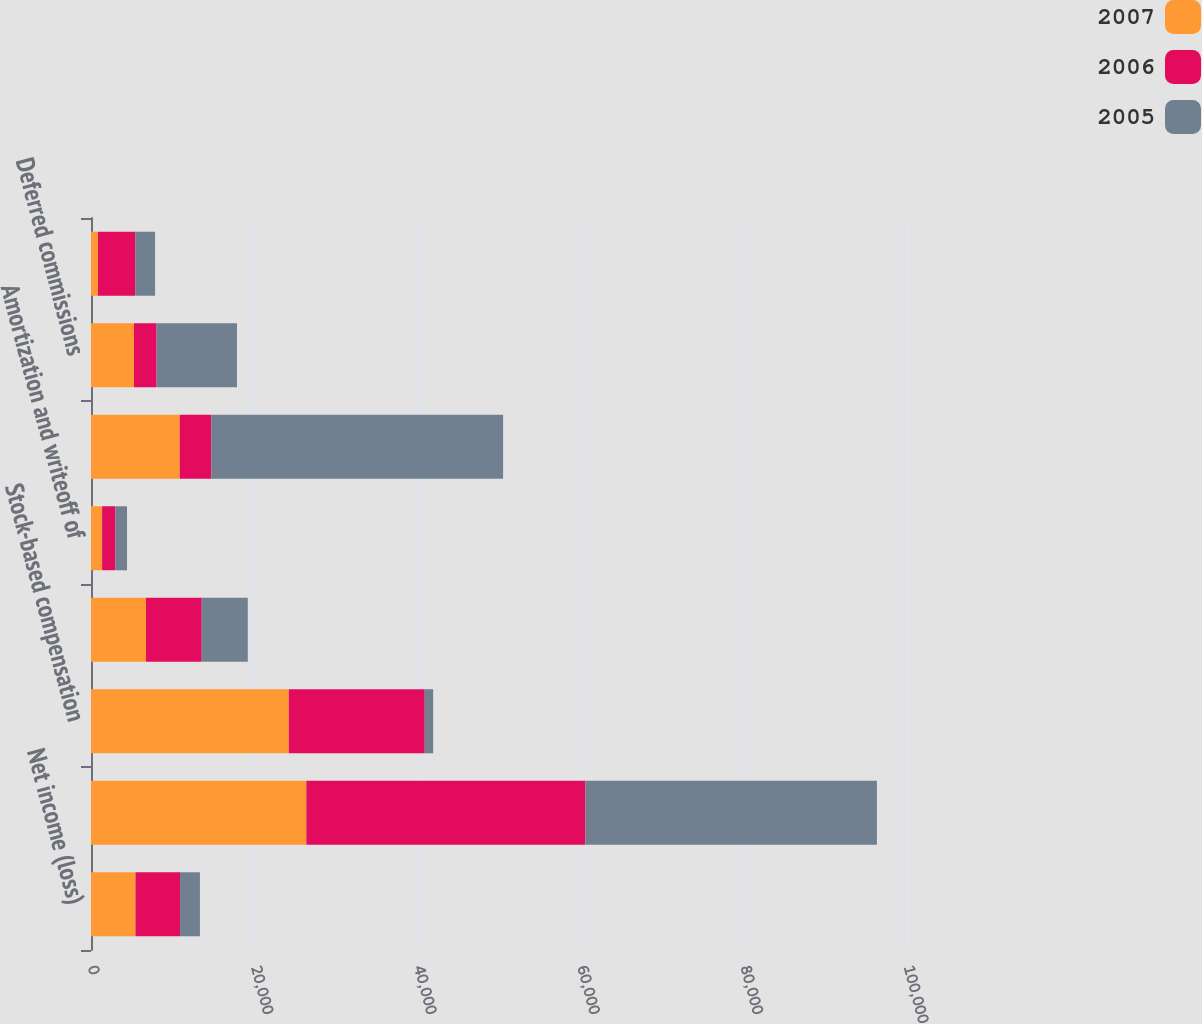<chart> <loc_0><loc_0><loc_500><loc_500><stacked_bar_chart><ecel><fcel>Net income (loss)<fcel>Depreciation and amortization<fcel>Stock-based compensation<fcel>Deferred taxes<fcel>Amortization and writeoff of<fcel>Fees receivable net<fcel>Deferred commissions<fcel>Prepaid expenses and other<nl><fcel>2007<fcel>5455<fcel>26389<fcel>24241<fcel>6740<fcel>1363<fcel>10880<fcel>5266<fcel>857<nl><fcel>2006<fcel>5455<fcel>34197<fcel>16660<fcel>6830<fcel>1627<fcel>3876<fcel>2774<fcel>4562<nl><fcel>2005<fcel>2437<fcel>35728<fcel>1030<fcel>5644<fcel>1424<fcel>35746<fcel>9850<fcel>2436<nl></chart> 